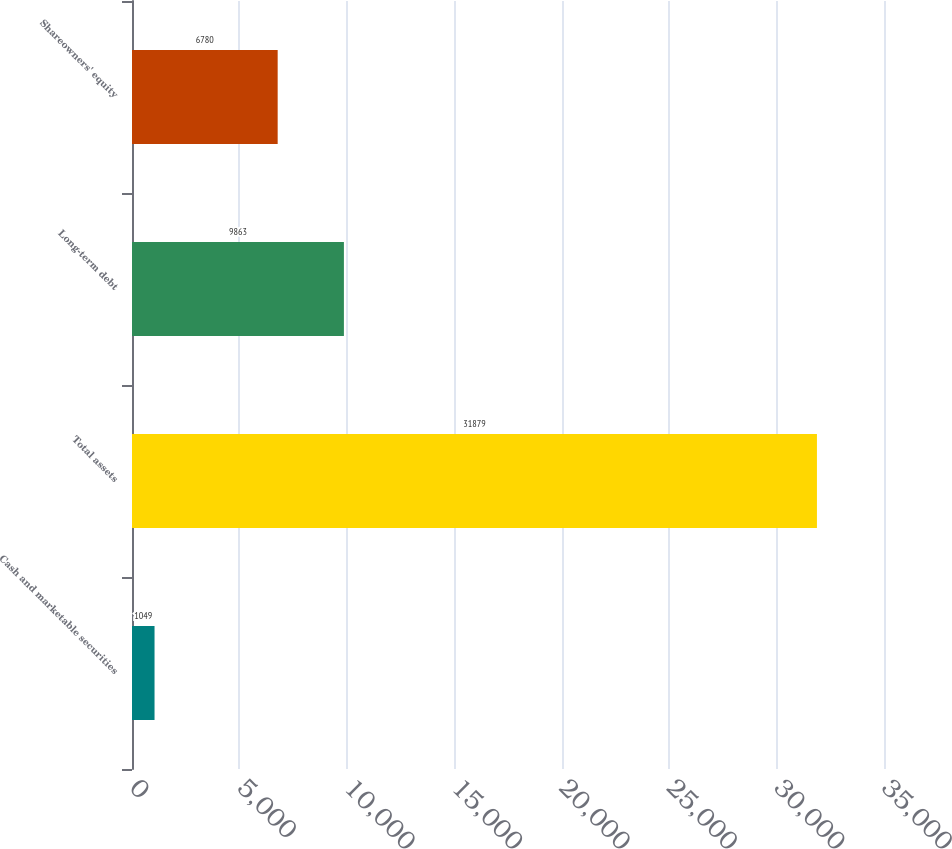<chart> <loc_0><loc_0><loc_500><loc_500><bar_chart><fcel>Cash and marketable securities<fcel>Total assets<fcel>Long-term debt<fcel>Shareowners' equity<nl><fcel>1049<fcel>31879<fcel>9863<fcel>6780<nl></chart> 